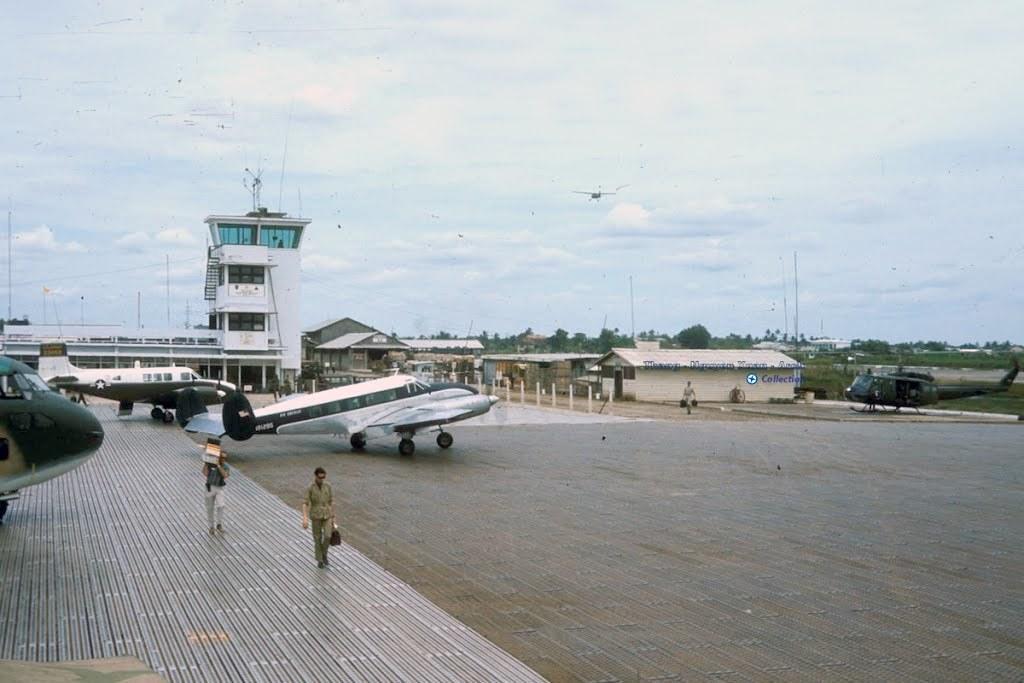In one or two sentences, can you explain what this image depicts? In this picture I can see there are few people walking and they are air planes in the backdrop and there are buildings, poles and trees and the sky is clear. 